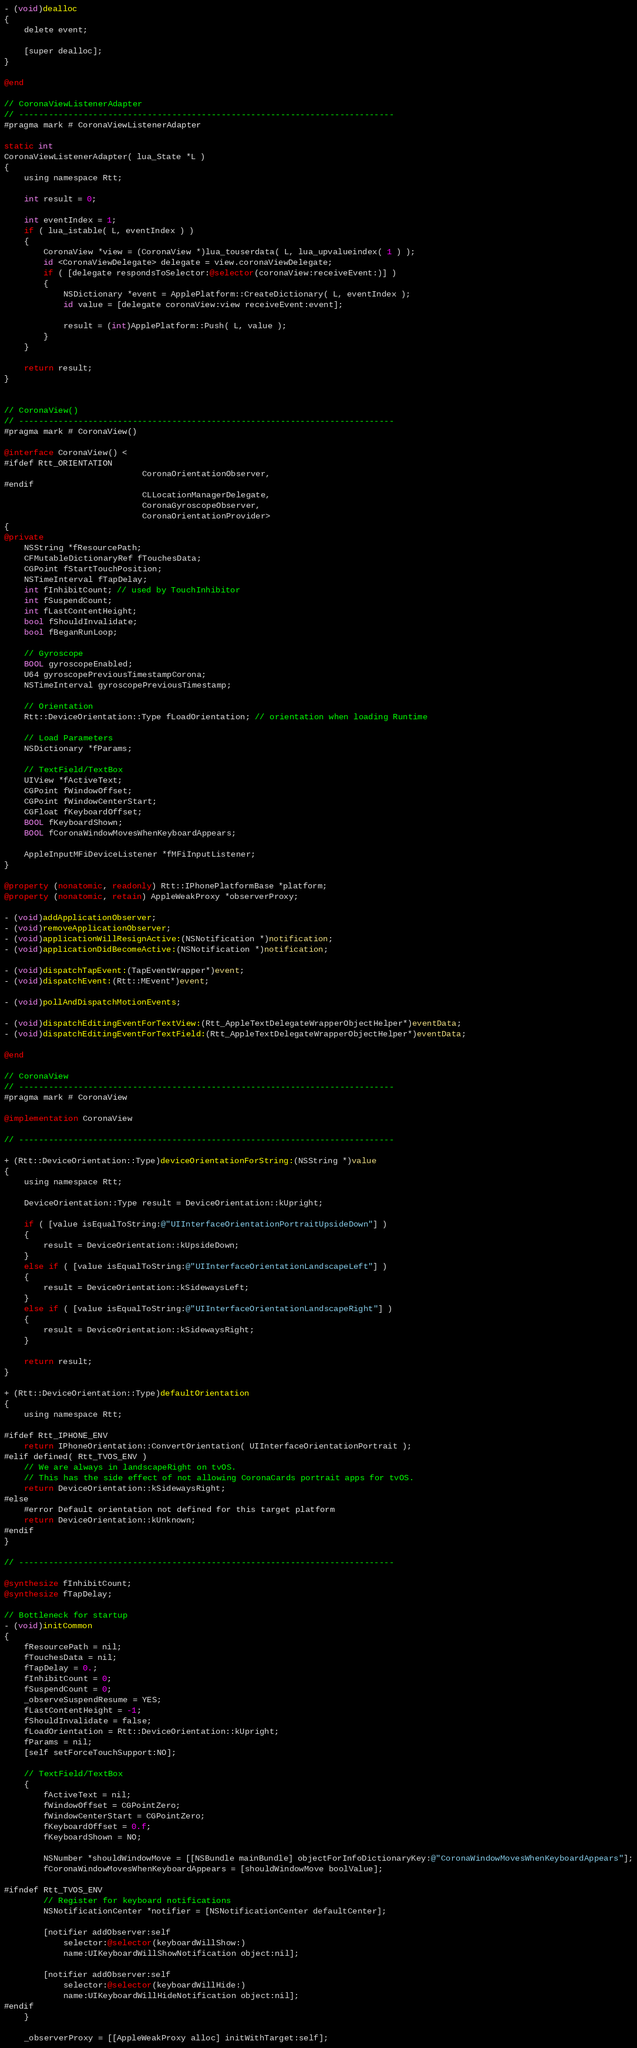<code> <loc_0><loc_0><loc_500><loc_500><_ObjectiveC_>- (void)dealloc
{
	delete event;

	[super dealloc];
}

@end

// CoronaViewListenerAdapter
// ----------------------------------------------------------------------------
#pragma mark # CoronaViewListenerAdapter

static int
CoronaViewListenerAdapter( lua_State *L )
{
	using namespace Rtt;

	int result = 0;

	int eventIndex = 1;
	if ( lua_istable( L, eventIndex ) )
	{
		CoronaView *view = (CoronaView *)lua_touserdata( L, lua_upvalueindex( 1 ) );
		id <CoronaViewDelegate> delegate = view.coronaViewDelegate;
		if ( [delegate respondsToSelector:@selector(coronaView:receiveEvent:)] )
		{
			NSDictionary *event = ApplePlatform::CreateDictionary( L, eventIndex );
			id value = [delegate coronaView:view receiveEvent:event];

			result = (int)ApplePlatform::Push( L, value );
		}
	}

	return result;
}


// CoronaView()
// ----------------------------------------------------------------------------
#pragma mark # CoronaView()

@interface CoronaView() <
#ifdef Rtt_ORIENTATION
							CoronaOrientationObserver,
#endif
							CLLocationManagerDelegate,
							CoronaGyroscopeObserver,
							CoronaOrientationProvider>
{
@private
	NSString *fResourcePath;
	CFMutableDictionaryRef fTouchesData;
	CGPoint fStartTouchPosition;
	NSTimeInterval fTapDelay;
	int fInhibitCount; // used by TouchInhibitor
	int fSuspendCount;
	int fLastContentHeight;
	bool fShouldInvalidate;
	bool fBeganRunLoop;

	// Gyroscope
	BOOL gyroscopeEnabled;
	U64 gyroscopePreviousTimestampCorona;
	NSTimeInterval gyroscopePreviousTimestamp;

	// Orientation
	Rtt::DeviceOrientation::Type fLoadOrientation; // orientation when loading Runtime

	// Load Parameters
	NSDictionary *fParams;

	// TextField/TextBox
	UIView *fActiveText;
	CGPoint fWindowOffset;
	CGPoint fWindowCenterStart;
	CGFloat fKeyboardOffset;
	BOOL fKeyboardShown;
	BOOL fCoronaWindowMovesWhenKeyboardAppears;

	AppleInputMFiDeviceListener *fMFiInputListener;
}

@property (nonatomic, readonly) Rtt::IPhonePlatformBase *platform;
@property (nonatomic, retain) AppleWeakProxy *observerProxy;

- (void)addApplicationObserver;
- (void)removeApplicationObserver;
- (void)applicationWillResignActive:(NSNotification *)notification;
- (void)applicationDidBecomeActive:(NSNotification *)notification;

- (void)dispatchTapEvent:(TapEventWrapper*)event;
- (void)dispatchEvent:(Rtt::MEvent*)event;

- (void)pollAndDispatchMotionEvents;

- (void)dispatchEditingEventForTextView:(Rtt_AppleTextDelegateWrapperObjectHelper*)eventData;
- (void)dispatchEditingEventForTextField:(Rtt_AppleTextDelegateWrapperObjectHelper*)eventData;

@end

// CoronaView
// ----------------------------------------------------------------------------
#pragma mark # CoronaView

@implementation CoronaView

// ----------------------------------------------------------------------------

+ (Rtt::DeviceOrientation::Type)deviceOrientationForString:(NSString *)value
{
	using namespace Rtt;

	DeviceOrientation::Type result = DeviceOrientation::kUpright;
	
	if ( [value isEqualToString:@"UIInterfaceOrientationPortraitUpsideDown"] )
	{
		result = DeviceOrientation::kUpsideDown;
	}
	else if ( [value isEqualToString:@"UIInterfaceOrientationLandscapeLeft"] )
	{
		result = DeviceOrientation::kSidewaysLeft;
	}
	else if ( [value isEqualToString:@"UIInterfaceOrientationLandscapeRight"] )
	{
		result = DeviceOrientation::kSidewaysRight;
	}

	return result;
}

+ (Rtt::DeviceOrientation::Type)defaultOrientation
{
	using namespace Rtt;
	
#ifdef Rtt_IPHONE_ENV
	return IPhoneOrientation::ConvertOrientation( UIInterfaceOrientationPortrait );
#elif defined( Rtt_TVOS_ENV )
	// We are always in landscapeRight on tvOS.
	// This has the side effect of not allowing CoronaCards portrait apps for tvOS.
	return DeviceOrientation::kSidewaysRight;
#else
	#error Default orientation not defined for this target platform
	return DeviceOrientation::kUnknown;
#endif
}

// ----------------------------------------------------------------------------

@synthesize fInhibitCount;
@synthesize fTapDelay;

// Bottleneck for startup
- (void)initCommon
{
	fResourcePath = nil;
	fTouchesData = nil;
	fTapDelay = 0.;
	fInhibitCount = 0;
	fSuspendCount = 0;
	_observeSuspendResume = YES;
	fLastContentHeight = -1;
	fShouldInvalidate = false;
	fLoadOrientation = Rtt::DeviceOrientation::kUpright;
	fParams = nil;
	[self setForceTouchSupport:NO];

	// TextField/TextBox
	{
		fActiveText = nil;
		fWindowOffset = CGPointZero;
		fWindowCenterStart = CGPointZero;
		fKeyboardOffset = 0.f;
		fKeyboardShown = NO;

		NSNumber *shouldWindowMove = [[NSBundle mainBundle] objectForInfoDictionaryKey:@"CoronaWindowMovesWhenKeyboardAppears"];
		fCoronaWindowMovesWhenKeyboardAppears = [shouldWindowMove boolValue];

#ifndef Rtt_TVOS_ENV
		// Register for keyboard notifications
		NSNotificationCenter *notifier = [NSNotificationCenter defaultCenter];

		[notifier addObserver:self
			selector:@selector(keyboardWillShow:)
			name:UIKeyboardWillShowNotification object:nil];

		[notifier addObserver:self
			selector:@selector(keyboardWillHide:)
			name:UIKeyboardWillHideNotification object:nil];
#endif
	}

	_observerProxy = [[AppleWeakProxy alloc] initWithTarget:self];</code> 